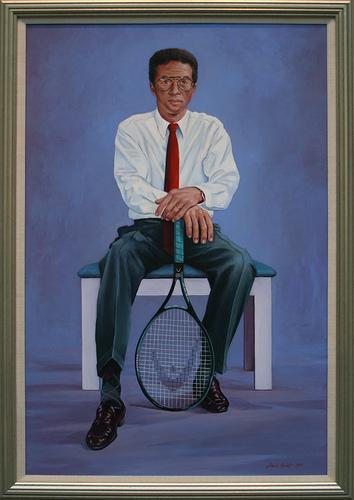What does he have in his hands?
Give a very brief answer. Tennis racket. What color is the man's tie?
Quick response, please. Red. How did this man die?
Quick response, please. Stress. 